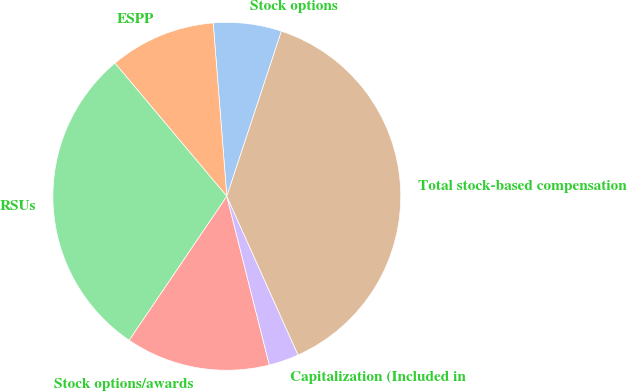<chart> <loc_0><loc_0><loc_500><loc_500><pie_chart><fcel>Stock options<fcel>ESPP<fcel>RSUs<fcel>Stock options/awards<fcel>Capitalization (Included in<fcel>Total stock-based compensation<nl><fcel>6.33%<fcel>9.87%<fcel>29.39%<fcel>13.41%<fcel>2.79%<fcel>38.19%<nl></chart> 